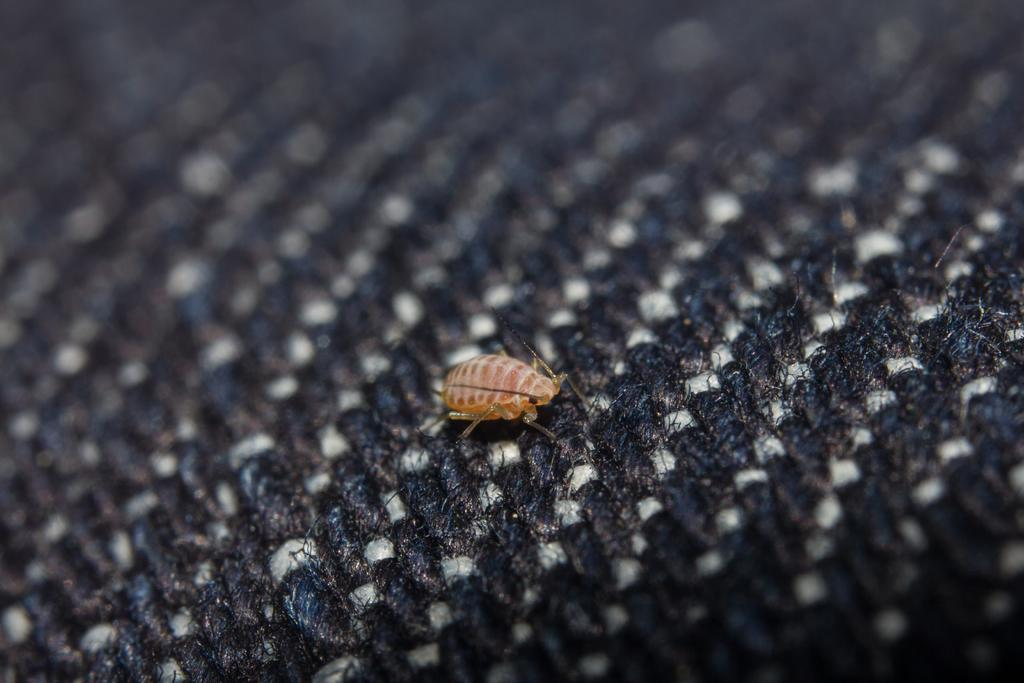What type of creature can be seen in the image? There is an insect in the image. Where is the insect located? The insect is on the cloth. What crime is the insect committing in the image? There is no crime being committed in the image; it simply shows an insect on a cloth. What invention is the insect using in the image? There is no invention being used by the insect in the image. 